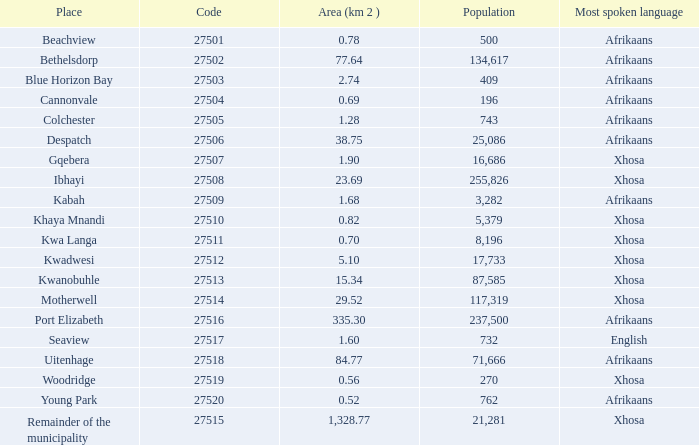In which location is xhosa spoken, the population is under 87,585, the area is less than 1.28 square kilometers, and the code is greater than 27504? Khaya Mnandi, Kwa Langa, Woodridge. 